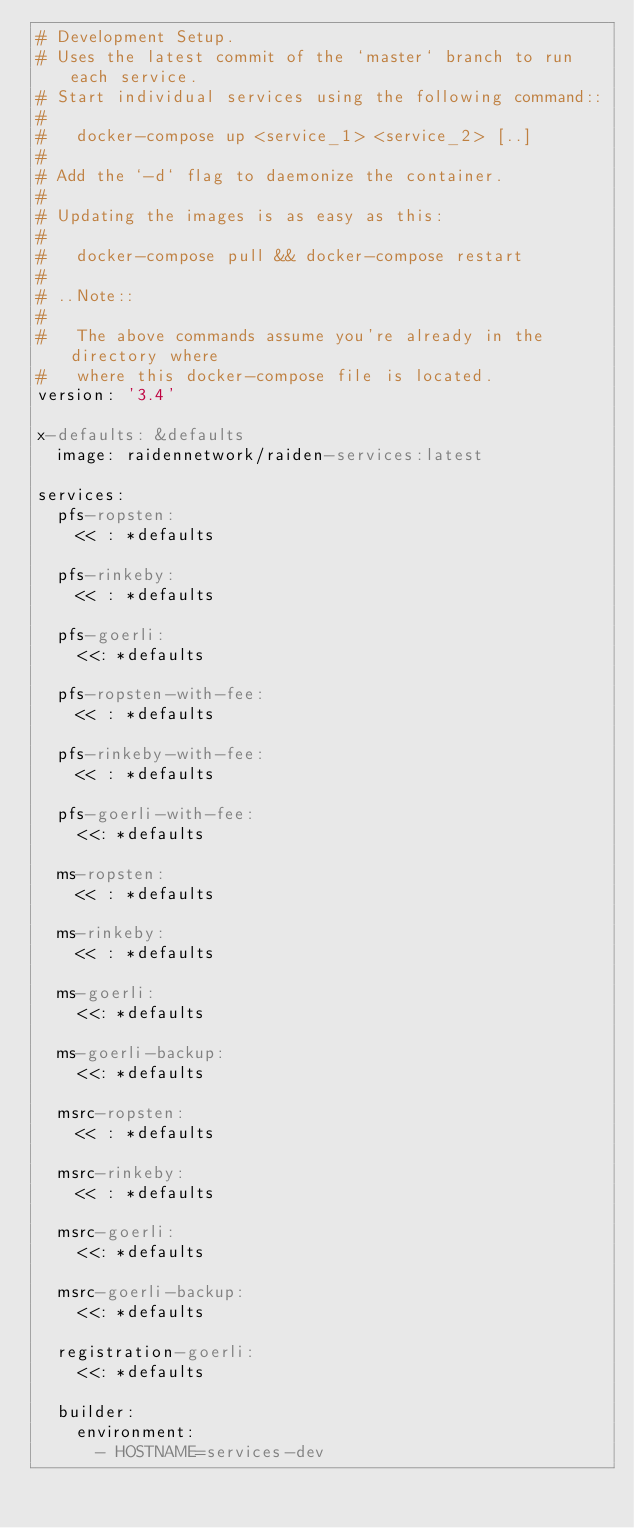Convert code to text. <code><loc_0><loc_0><loc_500><loc_500><_YAML_># Development Setup.
# Uses the latest commit of the `master` branch to run each service.
# Start individual services using the following command::
#
#   docker-compose up <service_1> <service_2> [..]
#
# Add the `-d` flag to daemonize the container.
#
# Updating the images is as easy as this:
#
#   docker-compose pull && docker-compose restart
#
# ..Note::
#
#   The above commands assume you're already in the directory where
#   where this docker-compose file is located.
version: '3.4'

x-defaults: &defaults
  image: raidennetwork/raiden-services:latest

services:
  pfs-ropsten:
    << : *defaults

  pfs-rinkeby:
    << : *defaults

  pfs-goerli:
    <<: *defaults

  pfs-ropsten-with-fee:
    << : *defaults

  pfs-rinkeby-with-fee:
    << : *defaults

  pfs-goerli-with-fee:
    <<: *defaults

  ms-ropsten:
    << : *defaults

  ms-rinkeby:
    << : *defaults

  ms-goerli:
    <<: *defaults

  ms-goerli-backup:
    <<: *defaults

  msrc-ropsten:
    << : *defaults

  msrc-rinkeby:
    << : *defaults

  msrc-goerli:
    <<: *defaults

  msrc-goerli-backup:
    <<: *defaults

  registration-goerli:
    <<: *defaults

  builder:
    environment:
      - HOSTNAME=services-dev
</code> 